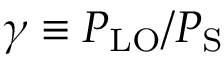<formula> <loc_0><loc_0><loc_500><loc_500>\gamma \equiv P _ { L O } / P _ { S }</formula> 